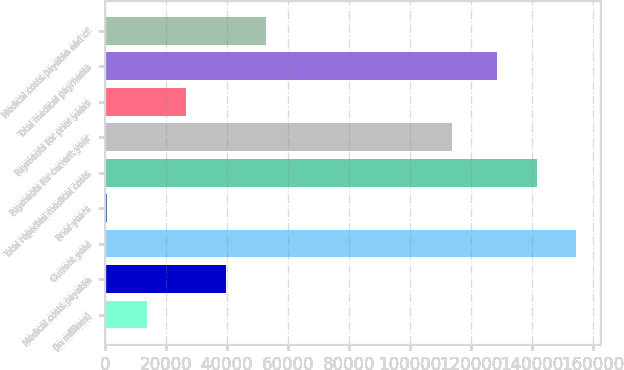<chart> <loc_0><loc_0><loc_500><loc_500><bar_chart><fcel>(in millions)<fcel>Medical costs payable<fcel>Current year<fcel>Prior years<fcel>Total reported medical costs<fcel>Payments for current year<fcel>Payments for prior years<fcel>Total medical payments<fcel>Medical costs payable end of<nl><fcel>13693.6<fcel>39700.8<fcel>154646<fcel>690<fcel>141643<fcel>113811<fcel>26697.2<fcel>128639<fcel>52704.4<nl></chart> 